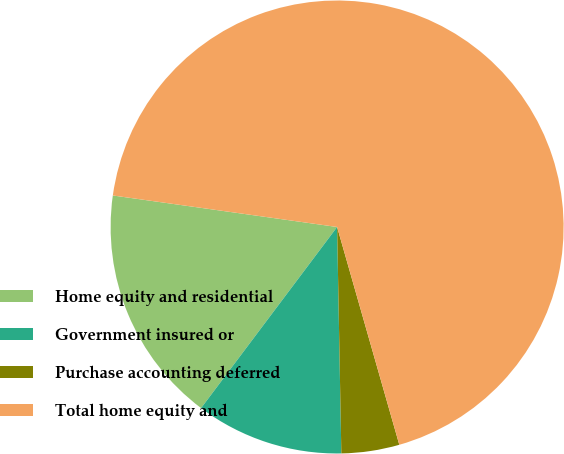Convert chart to OTSL. <chart><loc_0><loc_0><loc_500><loc_500><pie_chart><fcel>Home equity and residential<fcel>Government insured or<fcel>Purchase accounting deferred<fcel>Total home equity and<nl><fcel>16.97%<fcel>10.55%<fcel>4.13%<fcel>68.35%<nl></chart> 